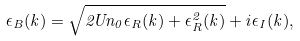Convert formula to latex. <formula><loc_0><loc_0><loc_500><loc_500>\epsilon _ { B } ( { k } ) = \sqrt { 2 U n _ { 0 } \epsilon _ { R } ( { k } ) + \epsilon _ { R } ^ { 2 } ( { k } ) } + i \epsilon _ { I } ( { k } ) ,</formula> 